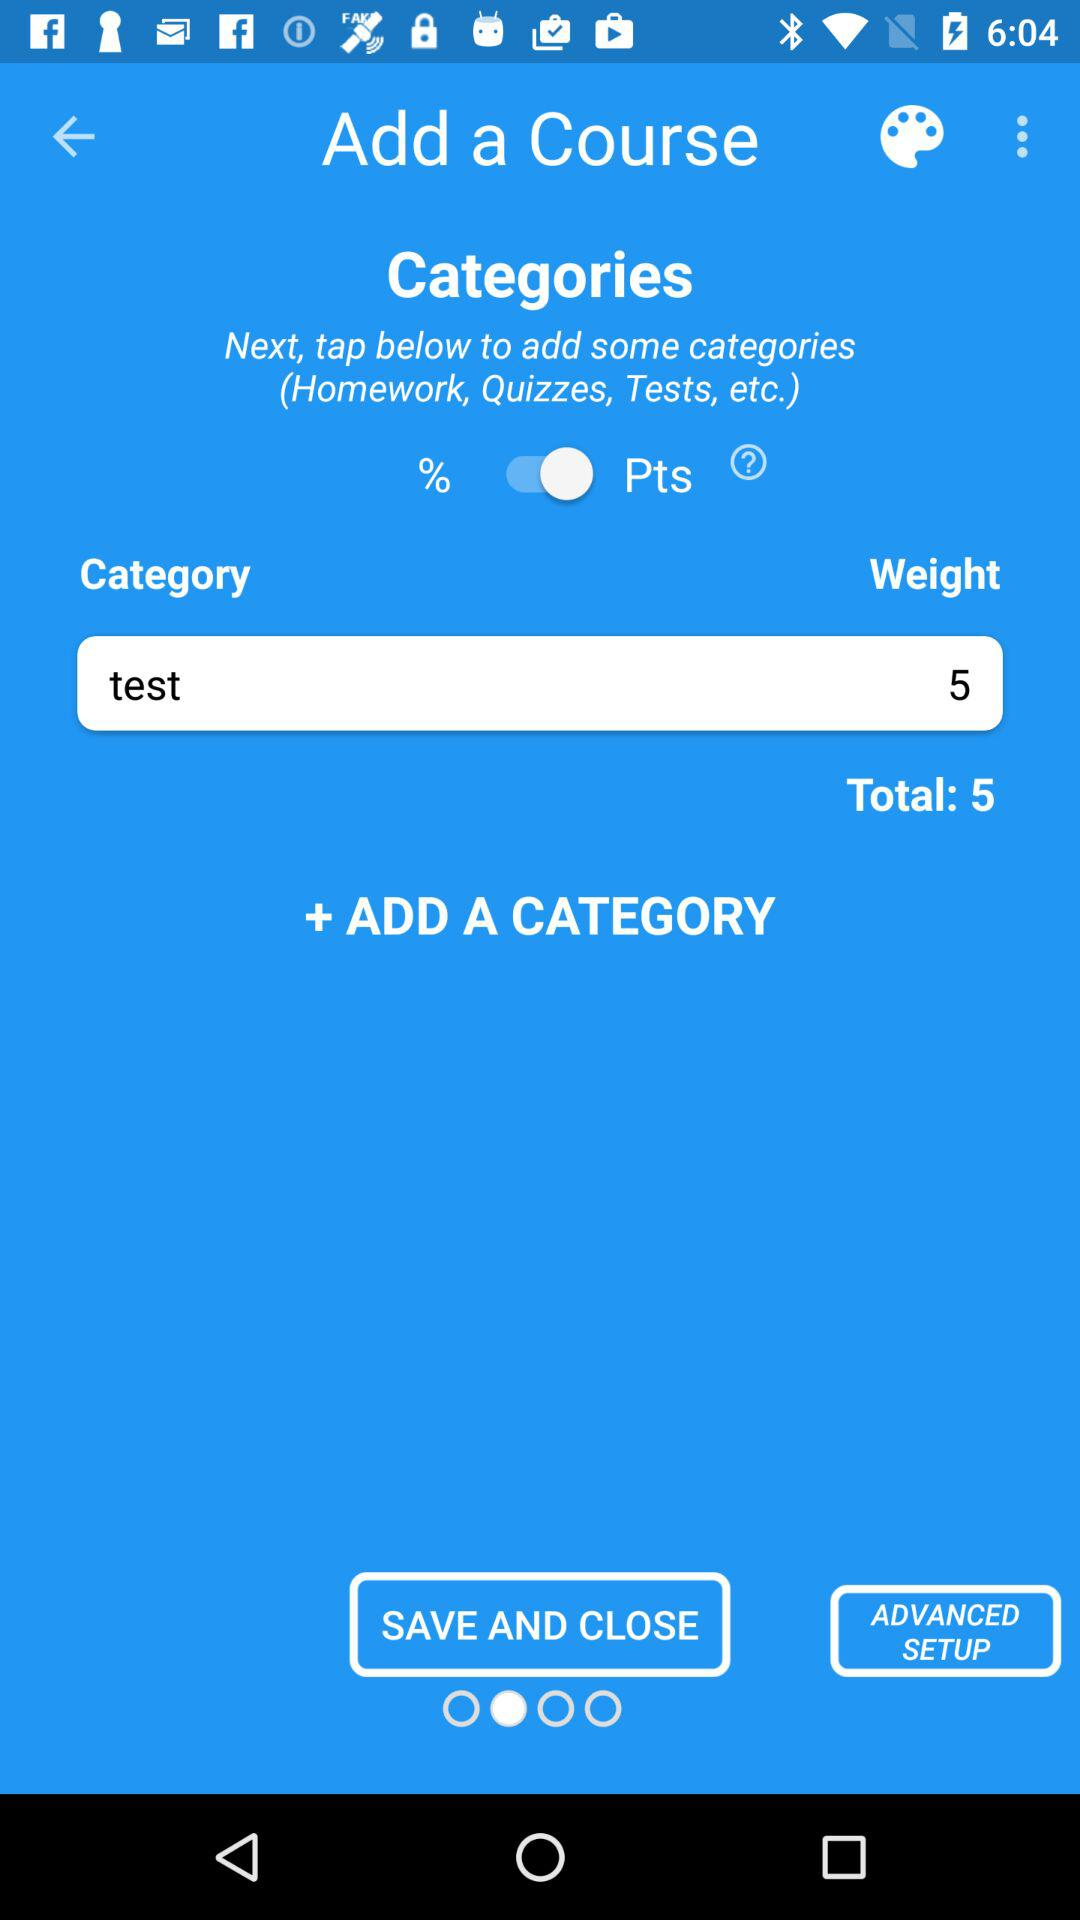How many points is the total weight of all categories?
Answer the question using a single word or phrase. 5 